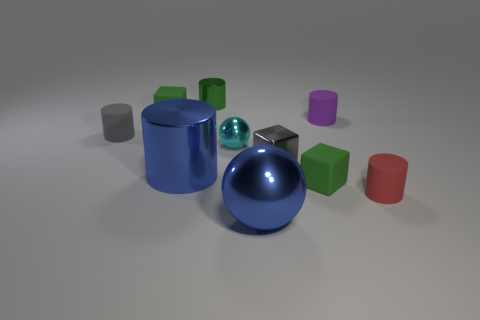There is a large metal ball; are there any red matte cylinders on the right side of it? yes 